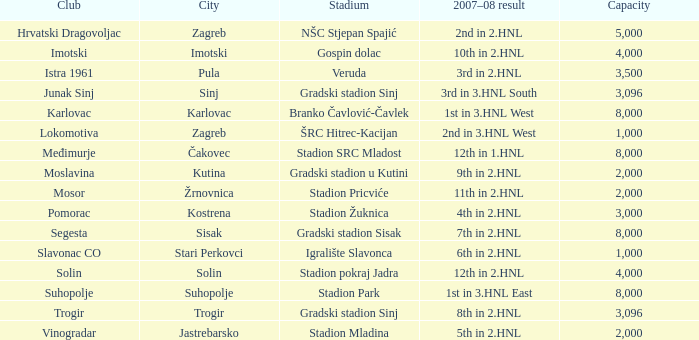What club has 3rd in 3.hnl south as the 2007-08 result? Junak Sinj. 